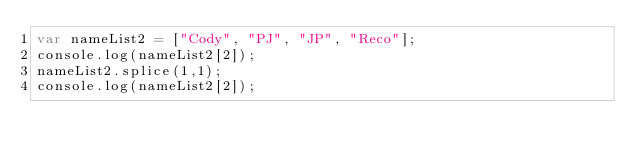Convert code to text. <code><loc_0><loc_0><loc_500><loc_500><_JavaScript_>var nameList2 = ["Cody", "PJ", "JP", "Reco"];
console.log(nameList2[2]);
nameList2.splice(1,1);
console.log(nameList2[2]);</code> 